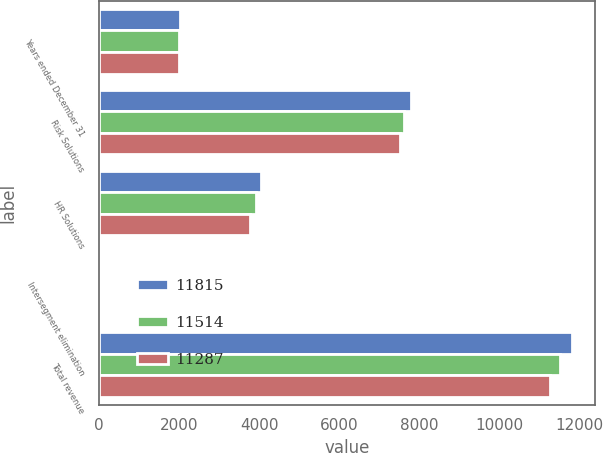Convert chart to OTSL. <chart><loc_0><loc_0><loc_500><loc_500><stacked_bar_chart><ecel><fcel>Years ended December 31<fcel>Risk Solutions<fcel>HR Solutions<fcel>Intersegment elimination<fcel>Total revenue<nl><fcel>11815<fcel>2013<fcel>7789<fcel>4057<fcel>31<fcel>11815<nl><fcel>11514<fcel>2012<fcel>7632<fcel>3925<fcel>43<fcel>11514<nl><fcel>11287<fcel>2011<fcel>7537<fcel>3781<fcel>31<fcel>11287<nl></chart> 